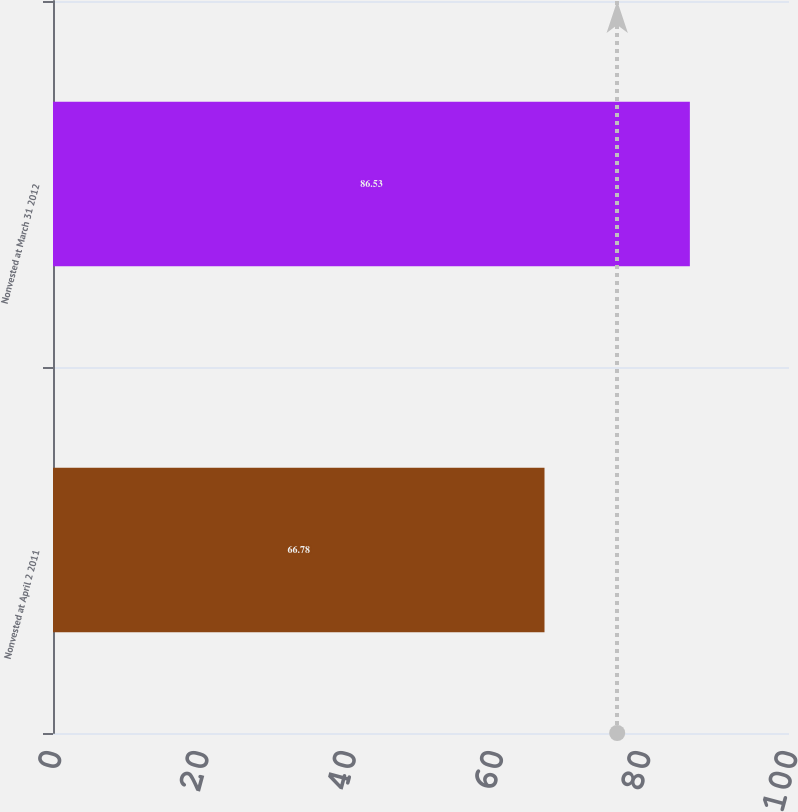<chart> <loc_0><loc_0><loc_500><loc_500><bar_chart><fcel>Nonvested at April 2 2011<fcel>Nonvested at March 31 2012<nl><fcel>66.78<fcel>86.53<nl></chart> 